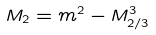<formula> <loc_0><loc_0><loc_500><loc_500>M _ { 2 } = m ^ { 2 } - M ^ { 3 } _ { 2 / 3 }</formula> 